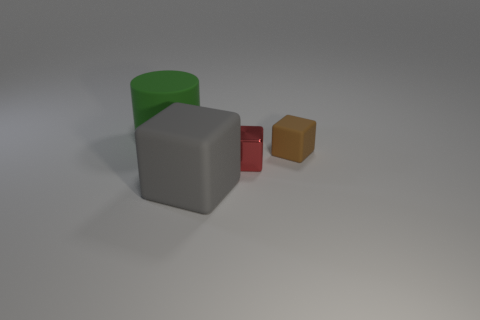Are there any other large green things that have the same shape as the large green rubber object?
Offer a terse response. No. There is a rubber cube that is behind the large thing on the right side of the green matte cylinder; how big is it?
Your answer should be compact. Small. There is a big rubber thing that is in front of the large matte thing that is on the left side of the big object in front of the green matte thing; what shape is it?
Provide a short and direct response. Cube. There is a green thing that is made of the same material as the large block; what size is it?
Offer a terse response. Large. Is the number of big blue metal objects greater than the number of large green matte cylinders?
Your response must be concise. No. There is a red thing that is the same size as the brown thing; what is it made of?
Provide a short and direct response. Metal. Does the cube that is in front of the red object have the same size as the green object?
Ensure brevity in your answer.  Yes. How many cylinders are either big green matte objects or big gray matte things?
Provide a short and direct response. 1. What is the material of the large thing behind the tiny matte object?
Ensure brevity in your answer.  Rubber. Is the number of small shiny blocks less than the number of tiny purple metal spheres?
Ensure brevity in your answer.  No. 